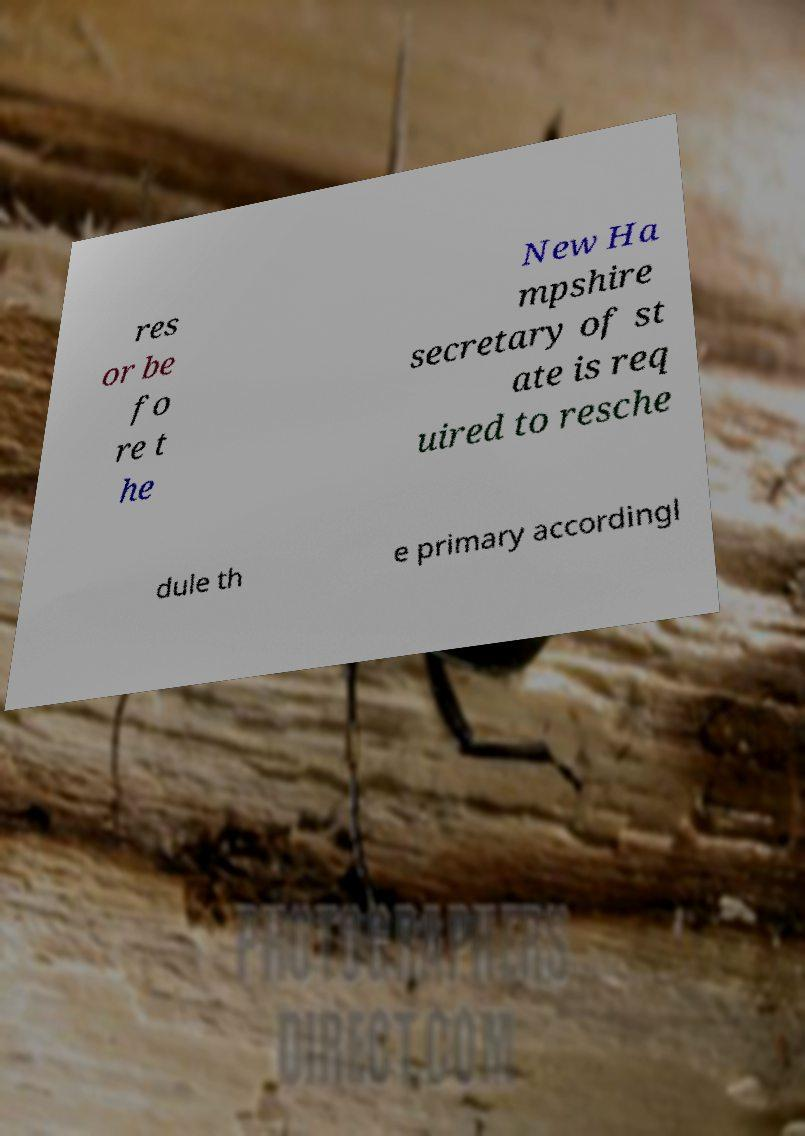For documentation purposes, I need the text within this image transcribed. Could you provide that? res or be fo re t he New Ha mpshire secretary of st ate is req uired to resche dule th e primary accordingl 